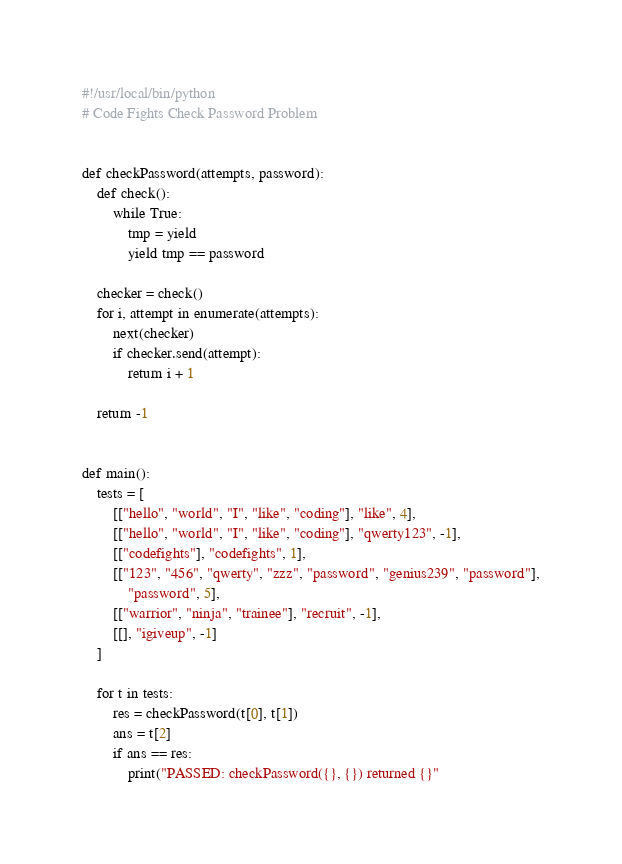<code> <loc_0><loc_0><loc_500><loc_500><_Python_>#!/usr/local/bin/python
# Code Fights Check Password Problem


def checkPassword(attempts, password):
    def check():
        while True:
            tmp = yield
            yield tmp == password

    checker = check()
    for i, attempt in enumerate(attempts):
        next(checker)
        if checker.send(attempt):
            return i + 1

    return -1


def main():
    tests = [
        [["hello", "world", "I", "like", "coding"], "like", 4],
        [["hello", "world", "I", "like", "coding"], "qwerty123", -1],
        [["codefights"], "codefights", 1],
        [["123", "456", "qwerty", "zzz", "password", "genius239", "password"],
            "password", 5],
        [["warrior", "ninja", "trainee"], "recruit", -1],
        [[], "igiveup", -1]
    ]

    for t in tests:
        res = checkPassword(t[0], t[1])
        ans = t[2]
        if ans == res:
            print("PASSED: checkPassword({}, {}) returned {}"</code> 